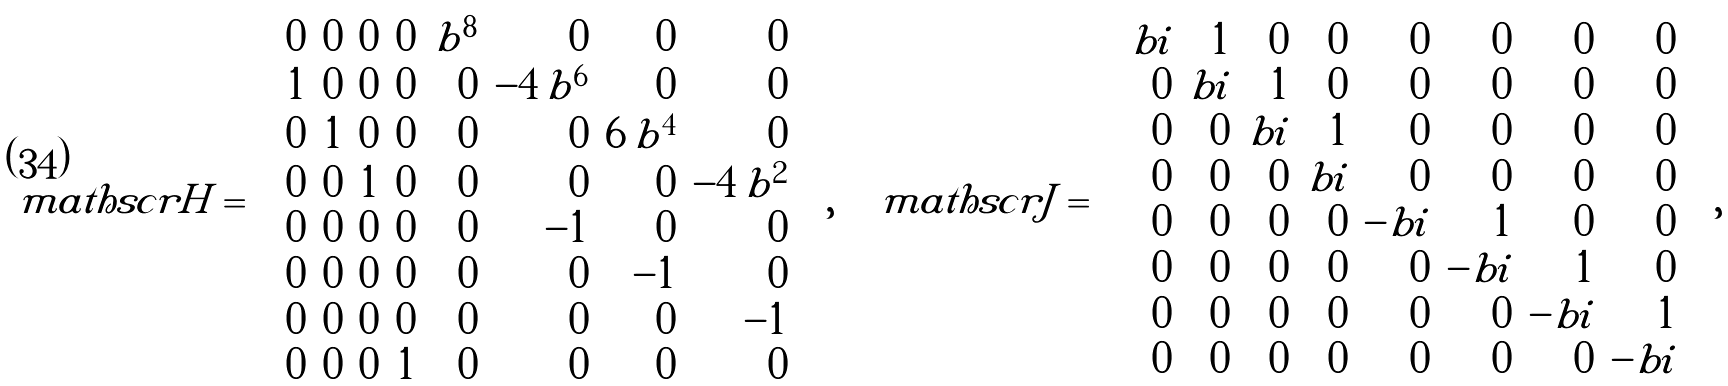Convert formula to latex. <formula><loc_0><loc_0><loc_500><loc_500>\ m a t h s c r { H } = \left [ \begin{array} { r r r r r r r r } 0 & 0 & 0 & 0 & b ^ { 8 } & 0 & 0 & 0 \\ 1 & 0 & 0 & 0 & 0 & - 4 \, b ^ { 6 } & 0 & 0 \\ 0 & 1 & 0 & 0 & 0 & 0 & 6 \, b ^ { 4 } & 0 \\ 0 & 0 & 1 & 0 & 0 & 0 & 0 & - 4 \, b ^ { 2 } \\ 0 & 0 & 0 & 0 & 0 & - 1 & 0 & 0 \\ 0 & 0 & 0 & 0 & 0 & 0 & - 1 & 0 \\ 0 & 0 & 0 & 0 & 0 & 0 & 0 & - 1 \\ 0 & 0 & 0 & 1 & 0 & 0 & 0 & 0 \end{array} \right ] , \quad \ m a t h s c r { J } = \left [ \begin{array} { r r r r r r r r } b i & 1 & 0 & 0 & 0 & 0 & 0 & 0 \\ 0 & b i & 1 & 0 & 0 & 0 & 0 & 0 \\ 0 & 0 & b i & 1 & 0 & 0 & 0 & 0 \\ 0 & 0 & 0 & b i & 0 & 0 & 0 & 0 \\ 0 & 0 & 0 & 0 & - b i & 1 & 0 & 0 \\ 0 & 0 & 0 & 0 & 0 & - b i & 1 & 0 \\ 0 & 0 & 0 & 0 & 0 & 0 & - b i & 1 \\ 0 & 0 & 0 & 0 & 0 & 0 & 0 & - b i \end{array} \right ] ,</formula> 